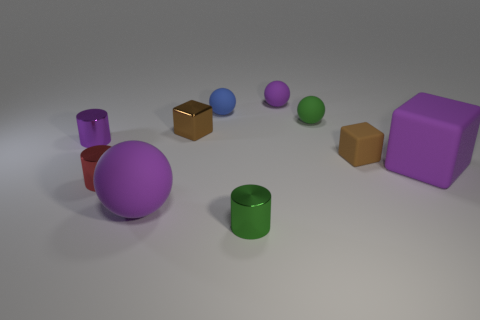Subtract 1 balls. How many balls are left? 3 Subtract all small brown cubes. How many cubes are left? 1 Subtract all gray balls. Subtract all cyan cylinders. How many balls are left? 4 Subtract all cylinders. How many objects are left? 7 Subtract all large brown rubber objects. Subtract all purple objects. How many objects are left? 6 Add 8 large purple matte spheres. How many large purple matte spheres are left? 9 Add 1 tiny matte things. How many tiny matte things exist? 5 Subtract 0 brown spheres. How many objects are left? 10 